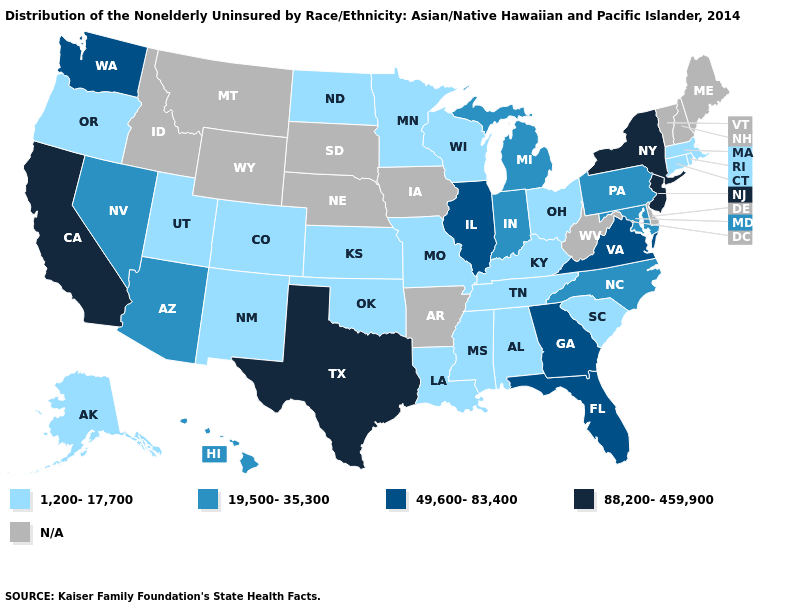Is the legend a continuous bar?
Short answer required. No. What is the highest value in states that border West Virginia?
Quick response, please. 49,600-83,400. What is the highest value in the USA?
Answer briefly. 88,200-459,900. Does the map have missing data?
Concise answer only. Yes. What is the highest value in the Northeast ?
Give a very brief answer. 88,200-459,900. What is the value of New Mexico?
Keep it brief. 1,200-17,700. What is the value of Texas?
Answer briefly. 88,200-459,900. What is the highest value in the USA?
Give a very brief answer. 88,200-459,900. What is the value of Alabama?
Keep it brief. 1,200-17,700. Name the states that have a value in the range 19,500-35,300?
Quick response, please. Arizona, Hawaii, Indiana, Maryland, Michigan, Nevada, North Carolina, Pennsylvania. What is the value of Hawaii?
Write a very short answer. 19,500-35,300. Name the states that have a value in the range 19,500-35,300?
Be succinct. Arizona, Hawaii, Indiana, Maryland, Michigan, Nevada, North Carolina, Pennsylvania. Does the first symbol in the legend represent the smallest category?
Keep it brief. Yes. What is the value of South Carolina?
Quick response, please. 1,200-17,700. What is the value of Nebraska?
Short answer required. N/A. 